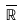<formula> <loc_0><loc_0><loc_500><loc_500>\overline { { \mathbb { R } } }</formula> 